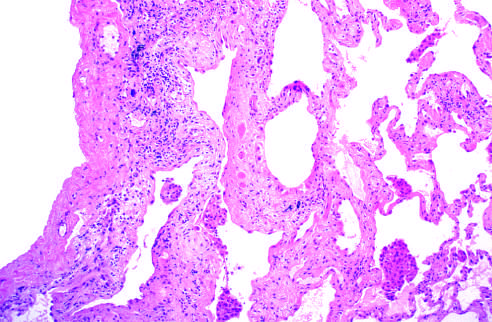s the fibrosis, which varies in intensity, more pronounced in the subpleural region?
Answer the question using a single word or phrase. Yes 